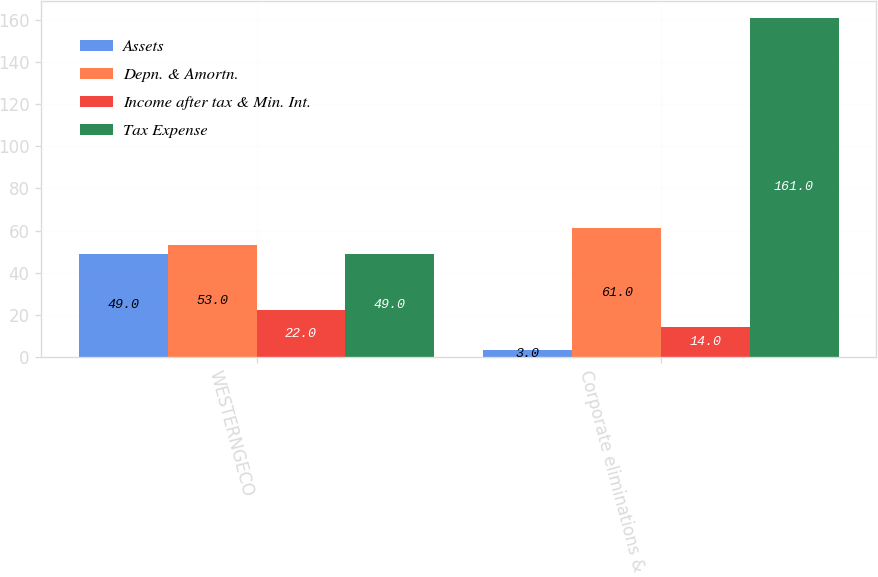Convert chart. <chart><loc_0><loc_0><loc_500><loc_500><stacked_bar_chart><ecel><fcel>WESTERNGECO<fcel>Corporate eliminations & Other<nl><fcel>Assets<fcel>49<fcel>3<nl><fcel>Depn. & Amortn.<fcel>53<fcel>61<nl><fcel>Income after tax & Min. Int.<fcel>22<fcel>14<nl><fcel>Tax Expense<fcel>49<fcel>161<nl></chart> 